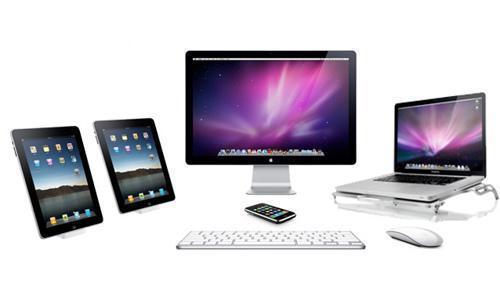What is in the middle?
Choose the correct response, then elucidate: 'Answer: answer
Rationale: rationale.'
Options: Cow, baby, pumpkin, laptop. Answer: laptop.
Rationale: A laptop is on the display. a desktop is actually in the middle. 